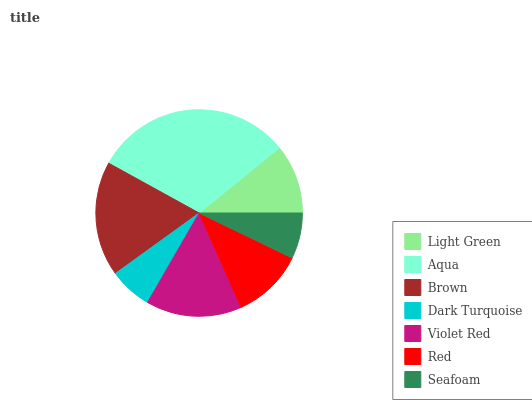Is Dark Turquoise the minimum?
Answer yes or no. Yes. Is Aqua the maximum?
Answer yes or no. Yes. Is Brown the minimum?
Answer yes or no. No. Is Brown the maximum?
Answer yes or no. No. Is Aqua greater than Brown?
Answer yes or no. Yes. Is Brown less than Aqua?
Answer yes or no. Yes. Is Brown greater than Aqua?
Answer yes or no. No. Is Aqua less than Brown?
Answer yes or no. No. Is Red the high median?
Answer yes or no. Yes. Is Red the low median?
Answer yes or no. Yes. Is Aqua the high median?
Answer yes or no. No. Is Dark Turquoise the low median?
Answer yes or no. No. 